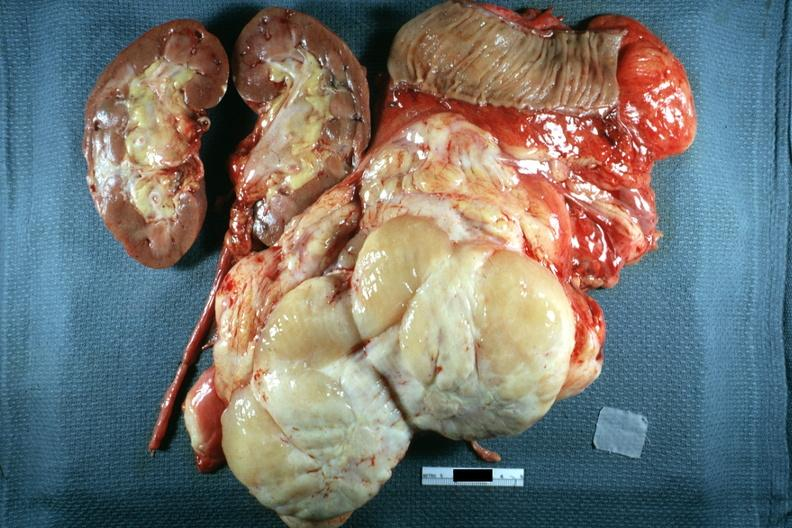s retroperitoneal liposarcoma present?
Answer the question using a single word or phrase. Yes 